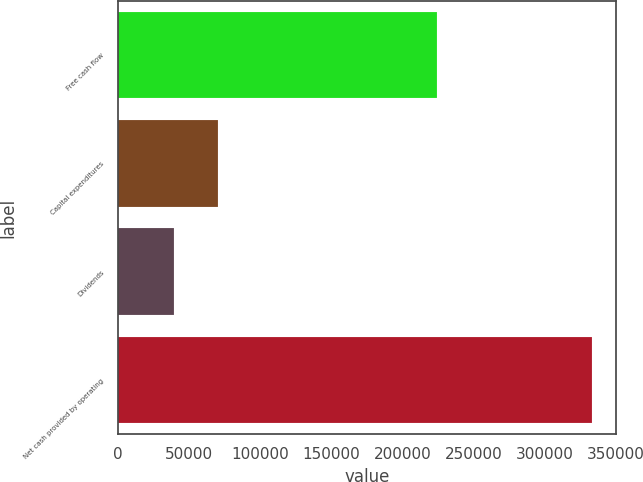Convert chart. <chart><loc_0><loc_0><loc_500><loc_500><bar_chart><fcel>Free cash flow<fcel>Capital expenditures<fcel>Dividends<fcel>Net cash provided by operating<nl><fcel>224288<fcel>69851<fcel>39320<fcel>333459<nl></chart> 